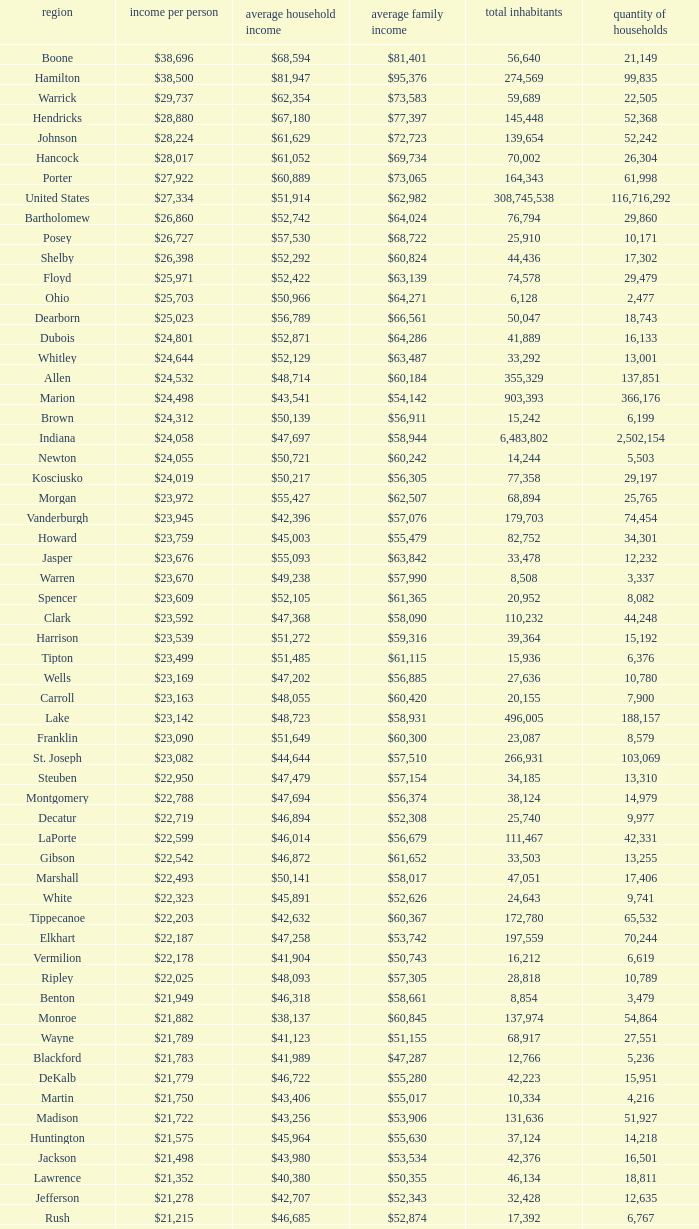What County has a Median household income of $46,872? Gibson. 